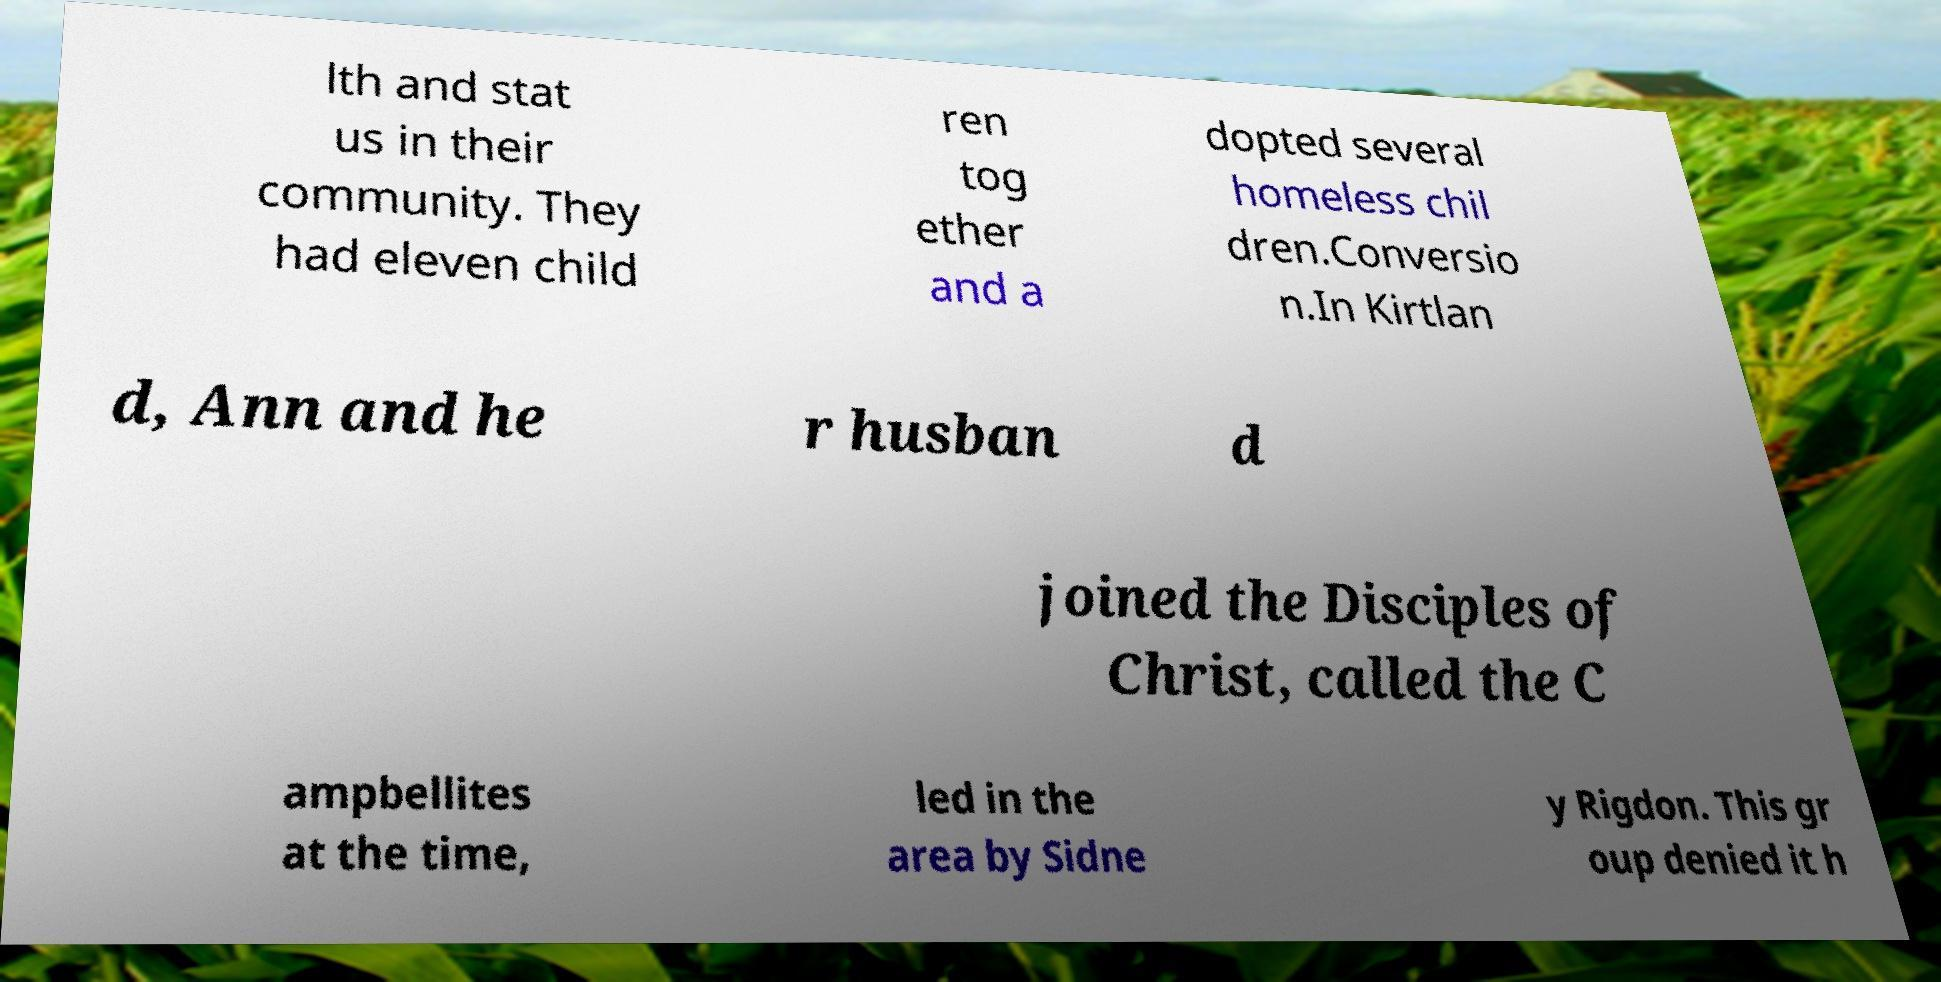Can you read and provide the text displayed in the image?This photo seems to have some interesting text. Can you extract and type it out for me? lth and stat us in their community. They had eleven child ren tog ether and a dopted several homeless chil dren.Conversio n.In Kirtlan d, Ann and he r husban d joined the Disciples of Christ, called the C ampbellites at the time, led in the area by Sidne y Rigdon. This gr oup denied it h 